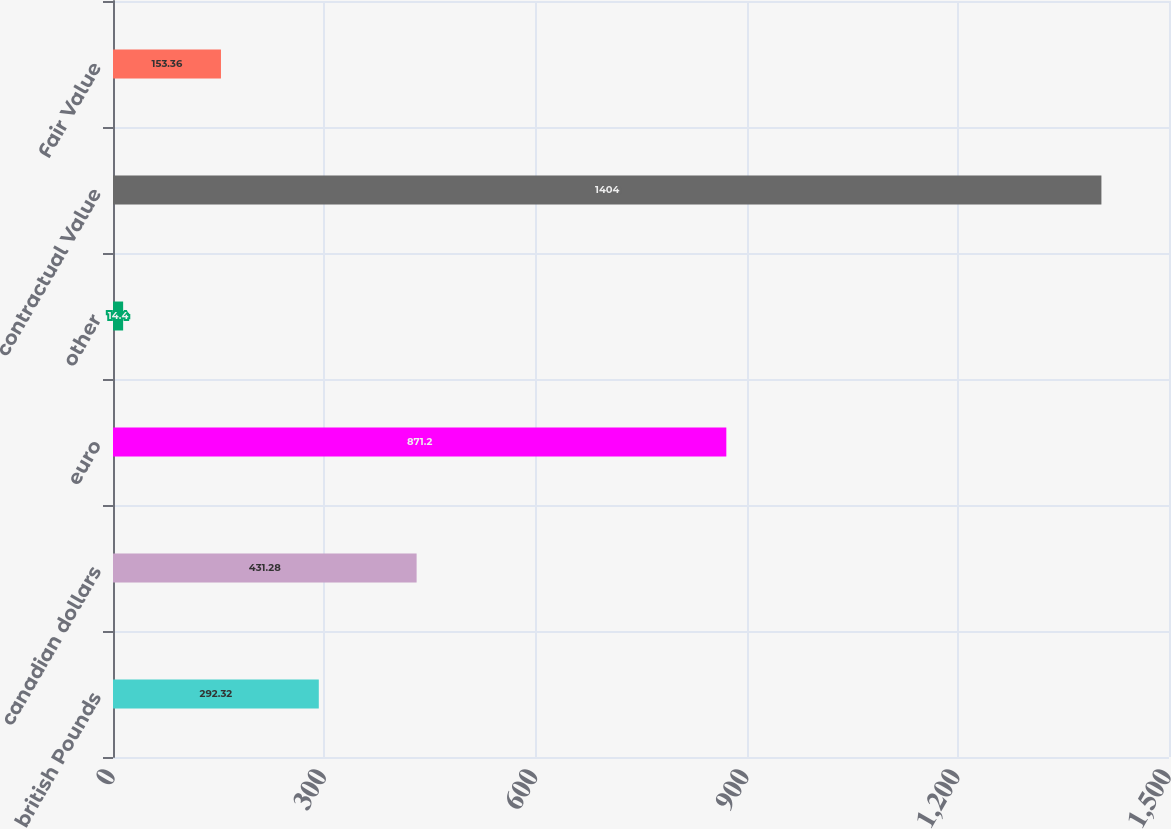Convert chart. <chart><loc_0><loc_0><loc_500><loc_500><bar_chart><fcel>british Pounds<fcel>canadian dollars<fcel>euro<fcel>other<fcel>contractual Value<fcel>Fair Value<nl><fcel>292.32<fcel>431.28<fcel>871.2<fcel>14.4<fcel>1404<fcel>153.36<nl></chart> 